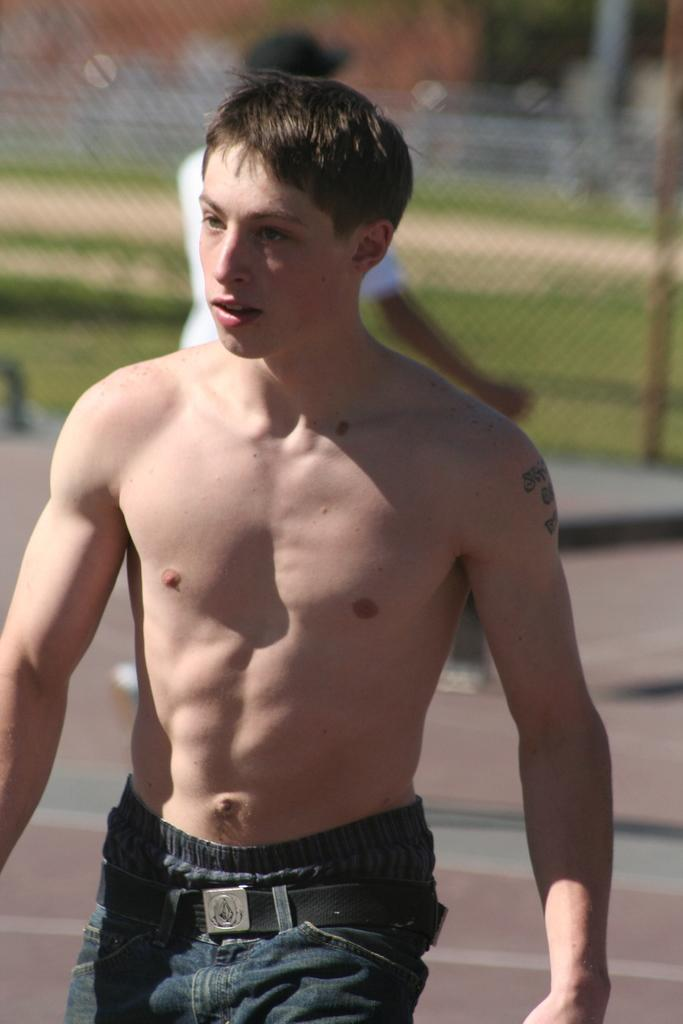What is the main subject in the foreground of the image? There is a person in the foreground of the image. Can you describe the background of the image? There is another person, a net, and grass in the background of the image. What type of surface is visible at the bottom of the image? There is a walkway at the bottom of the image. What is the title of the book the person in the foreground is reading in the image? There is no book visible in the image, so it is not possible to determine the title. 